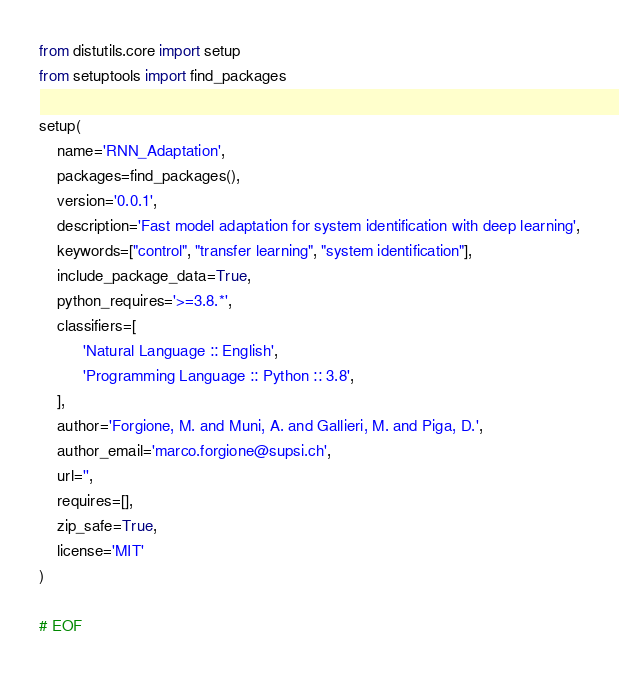<code> <loc_0><loc_0><loc_500><loc_500><_Python_>from distutils.core import setup
from setuptools import find_packages

setup(
    name='RNN_Adaptation',
    packages=find_packages(),
    version='0.0.1',
    description='Fast model adaptation for system identification with deep learning',
    keywords=["control", "transfer learning", "system identification"],
    include_package_data=True,
    python_requires='>=3.8.*',
    classifiers=[
          'Natural Language :: English',
          'Programming Language :: Python :: 3.8',
    ],
    author='Forgione, M. and Muni, A. and Gallieri, M. and Piga, D.',
    author_email='marco.forgione@supsi.ch',
    url='',
    requires=[],
    zip_safe=True,
    license='MIT'
)

# EOF
</code> 